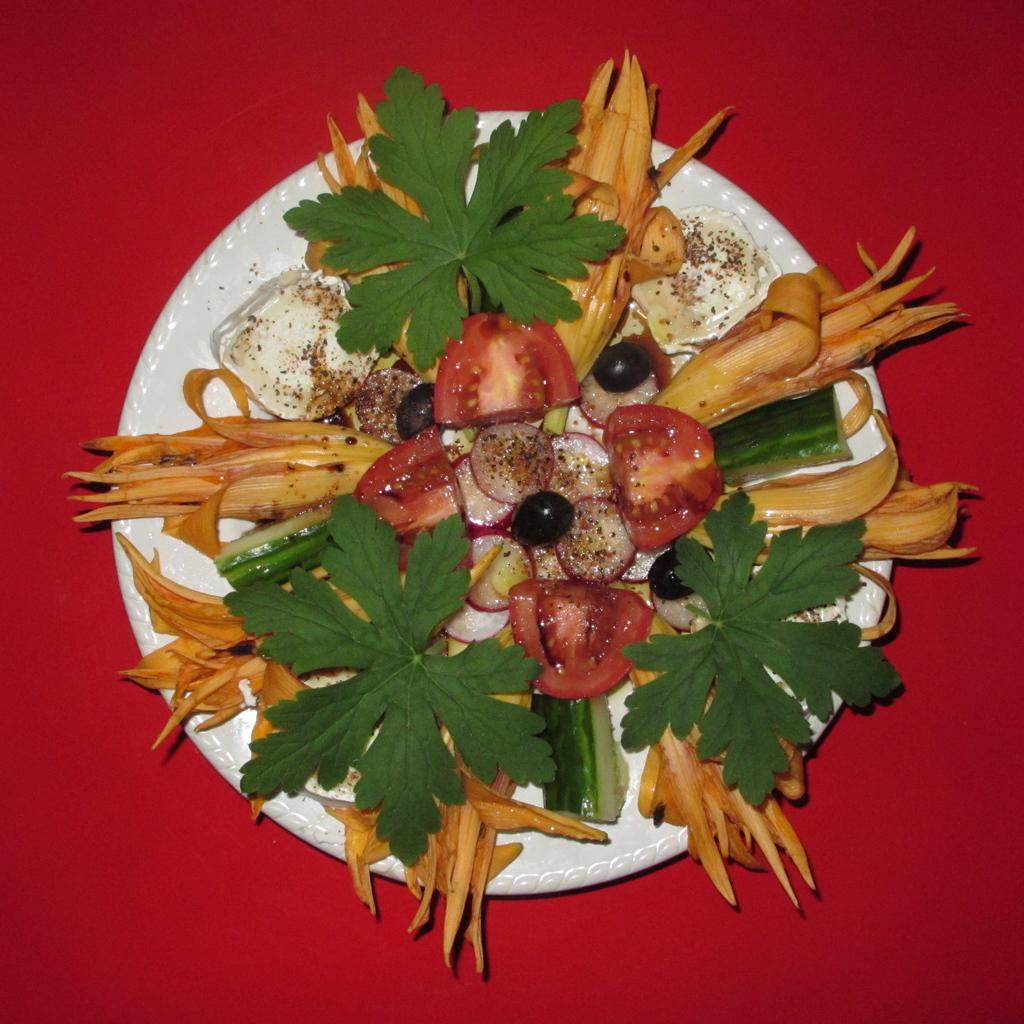What object can be seen in the image that is typically used for serving food? There is a plate in the image that is typically used for serving food. What is on the plate in the image? There is food on the plate in the image. What type of circle is depicted in the image? There is no circle present in the image. Is there any evidence of war in the image? There is no indication of war in the image; it features a plate with food on it. Who is the friend in the image? There is no friend present in the image; it only shows a plate with food on it. 